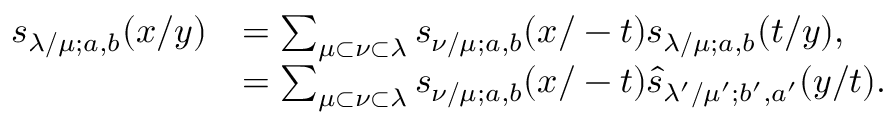Convert formula to latex. <formula><loc_0><loc_0><loc_500><loc_500>\begin{array} { r l } { s _ { \lambda / \mu ; a , b } ( x / y ) } & { = \sum _ { \mu \subset \nu \subset \lambda } s _ { \nu / \mu ; a , b } ( x / - t ) s _ { \lambda / \mu ; a , b } ( t / y ) , } \\ & { = \sum _ { \mu \subset \nu \subset \lambda } s _ { \nu / \mu ; a , b } ( x / - t ) \widehat { s } _ { \lambda ^ { \prime } / \mu ^ { \prime } ; b ^ { \prime } , a ^ { \prime } } ( y / t ) . } \end{array}</formula> 